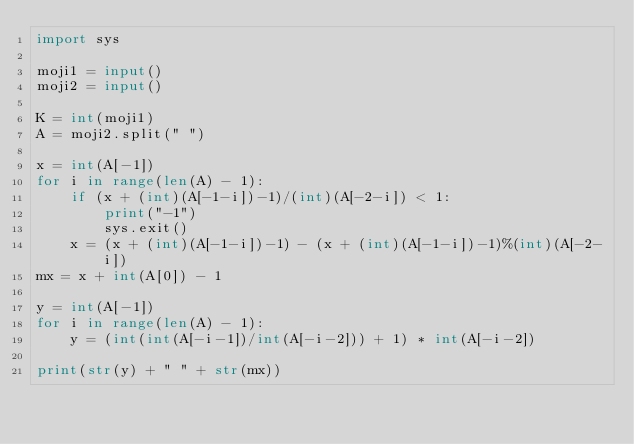Convert code to text. <code><loc_0><loc_0><loc_500><loc_500><_Python_>import sys

moji1 = input()
moji2 = input()

K = int(moji1)
A = moji2.split(" ")

x = int(A[-1])
for i in range(len(A) - 1):
    if (x + (int)(A[-1-i])-1)/(int)(A[-2-i]) < 1:
        print("-1")
        sys.exit()
    x = (x + (int)(A[-1-i])-1) - (x + (int)(A[-1-i])-1)%(int)(A[-2-i])
mx = x + int(A[0]) - 1

y = int(A[-1])
for i in range(len(A) - 1):
    y = (int(int(A[-i-1])/int(A[-i-2])) + 1) * int(A[-i-2])

print(str(y) + " " + str(mx))
</code> 